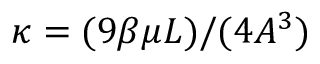Convert formula to latex. <formula><loc_0><loc_0><loc_500><loc_500>\kappa = ( 9 \beta \mu L ) / ( 4 A ^ { 3 } )</formula> 